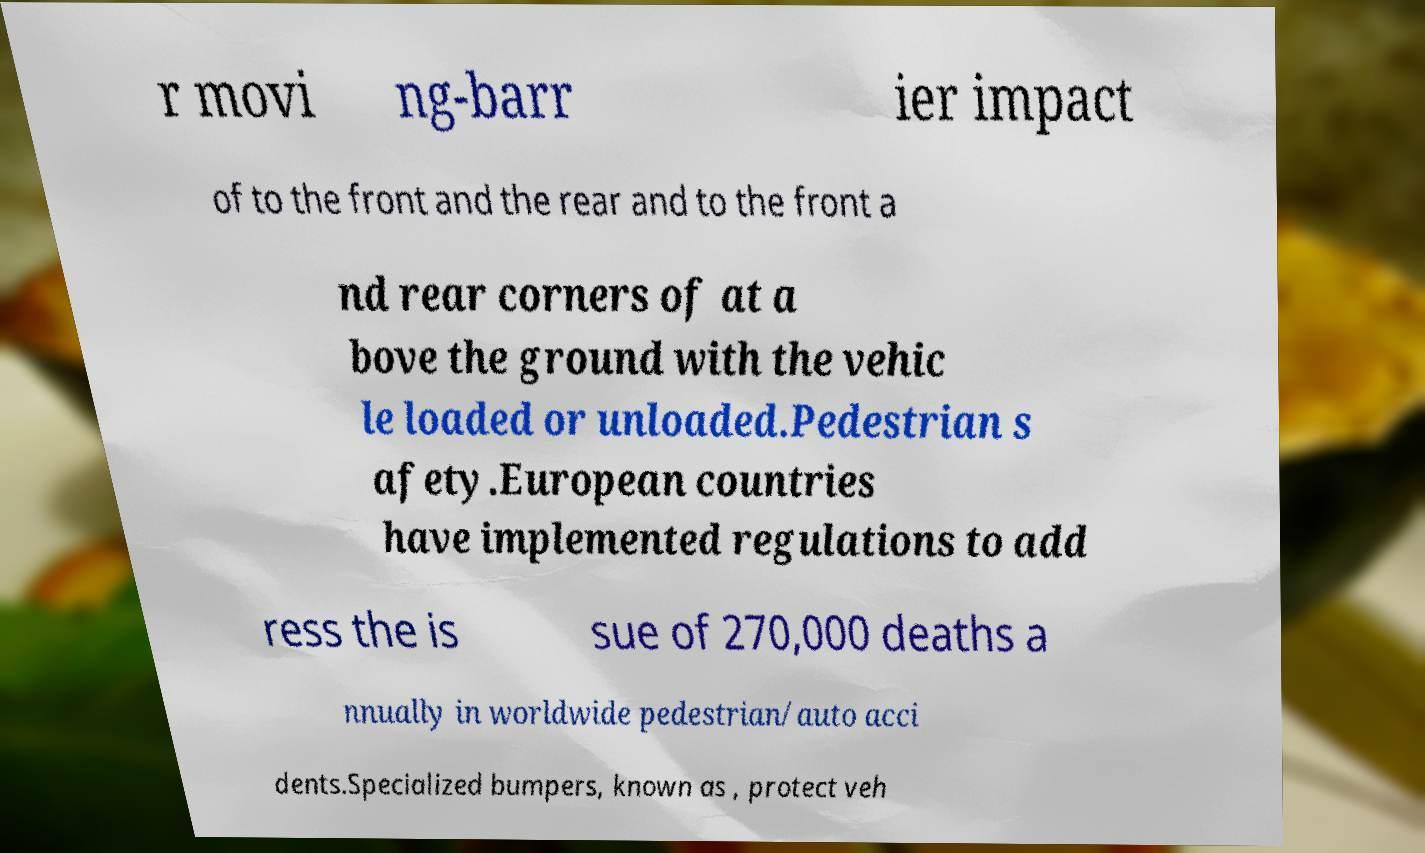For documentation purposes, I need the text within this image transcribed. Could you provide that? r movi ng-barr ier impact of to the front and the rear and to the front a nd rear corners of at a bove the ground with the vehic le loaded or unloaded.Pedestrian s afety.European countries have implemented regulations to add ress the is sue of 270,000 deaths a nnually in worldwide pedestrian/auto acci dents.Specialized bumpers, known as , protect veh 